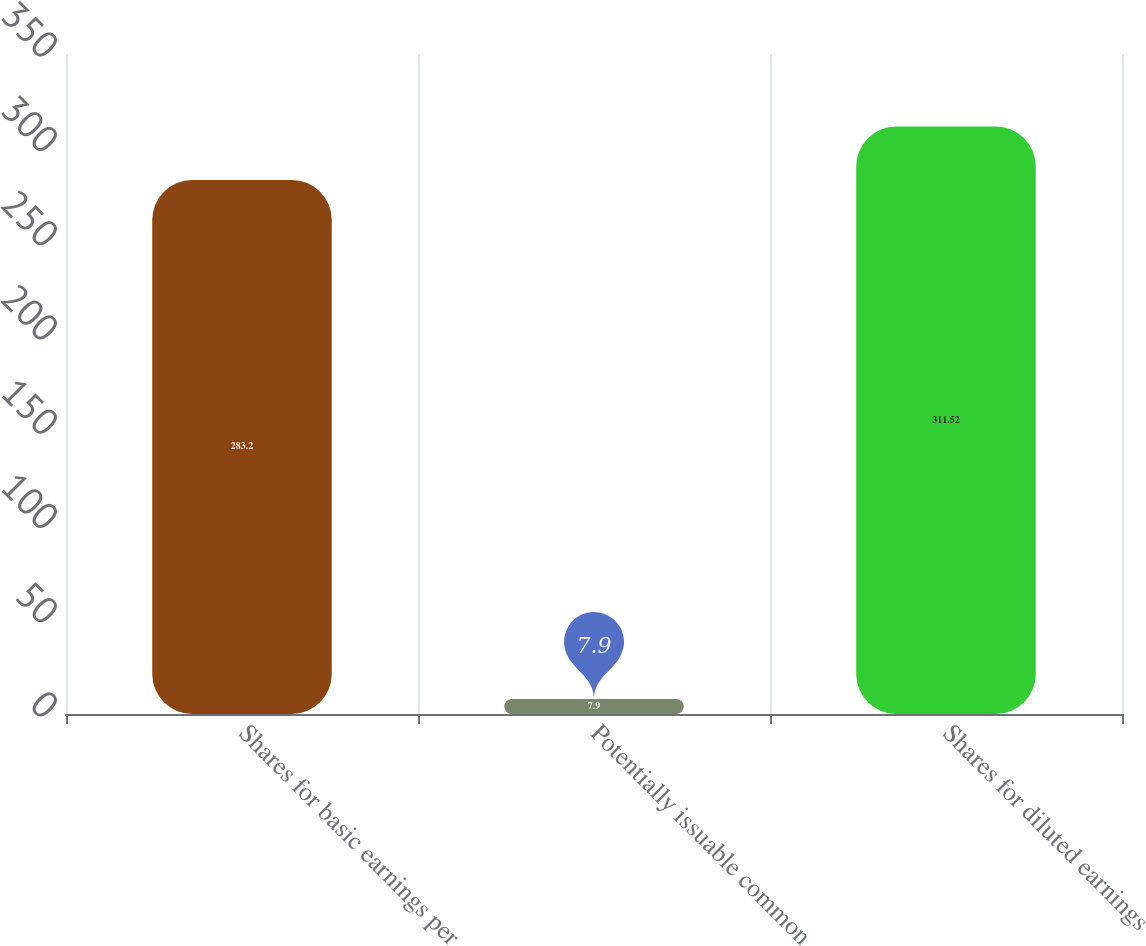Convert chart to OTSL. <chart><loc_0><loc_0><loc_500><loc_500><bar_chart><fcel>Shares for basic earnings per<fcel>Potentially issuable common<fcel>Shares for diluted earnings<nl><fcel>283.2<fcel>7.9<fcel>311.52<nl></chart> 